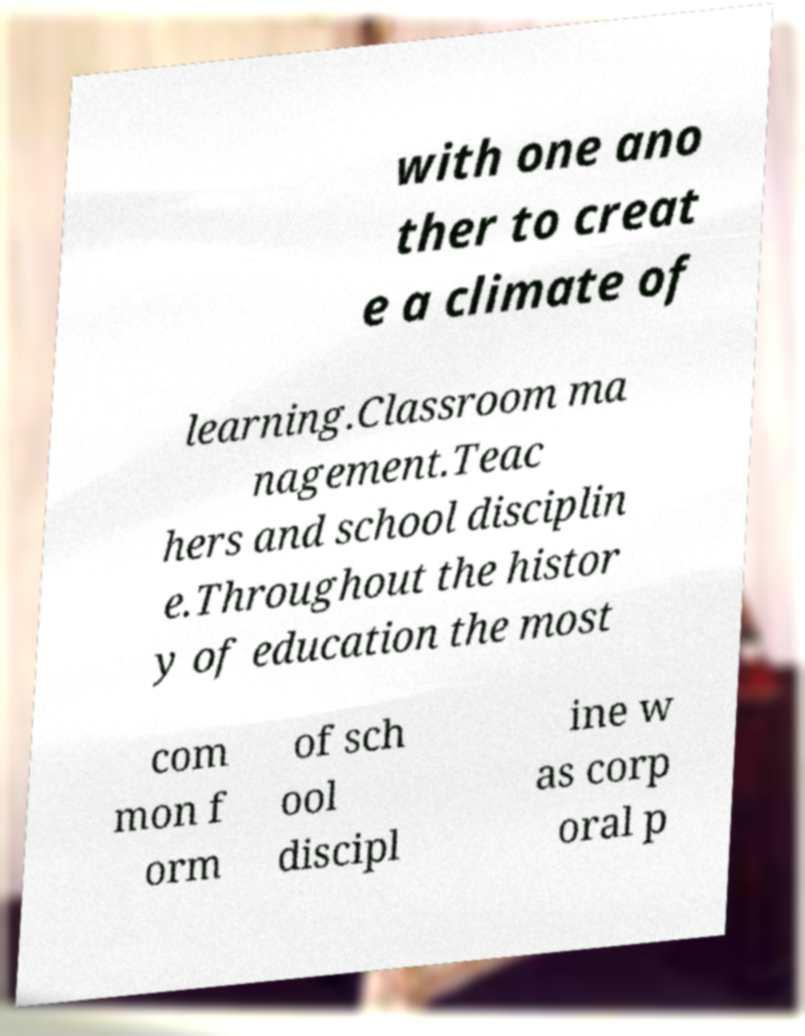Can you read and provide the text displayed in the image?This photo seems to have some interesting text. Can you extract and type it out for me? with one ano ther to creat e a climate of learning.Classroom ma nagement.Teac hers and school disciplin e.Throughout the histor y of education the most com mon f orm of sch ool discipl ine w as corp oral p 